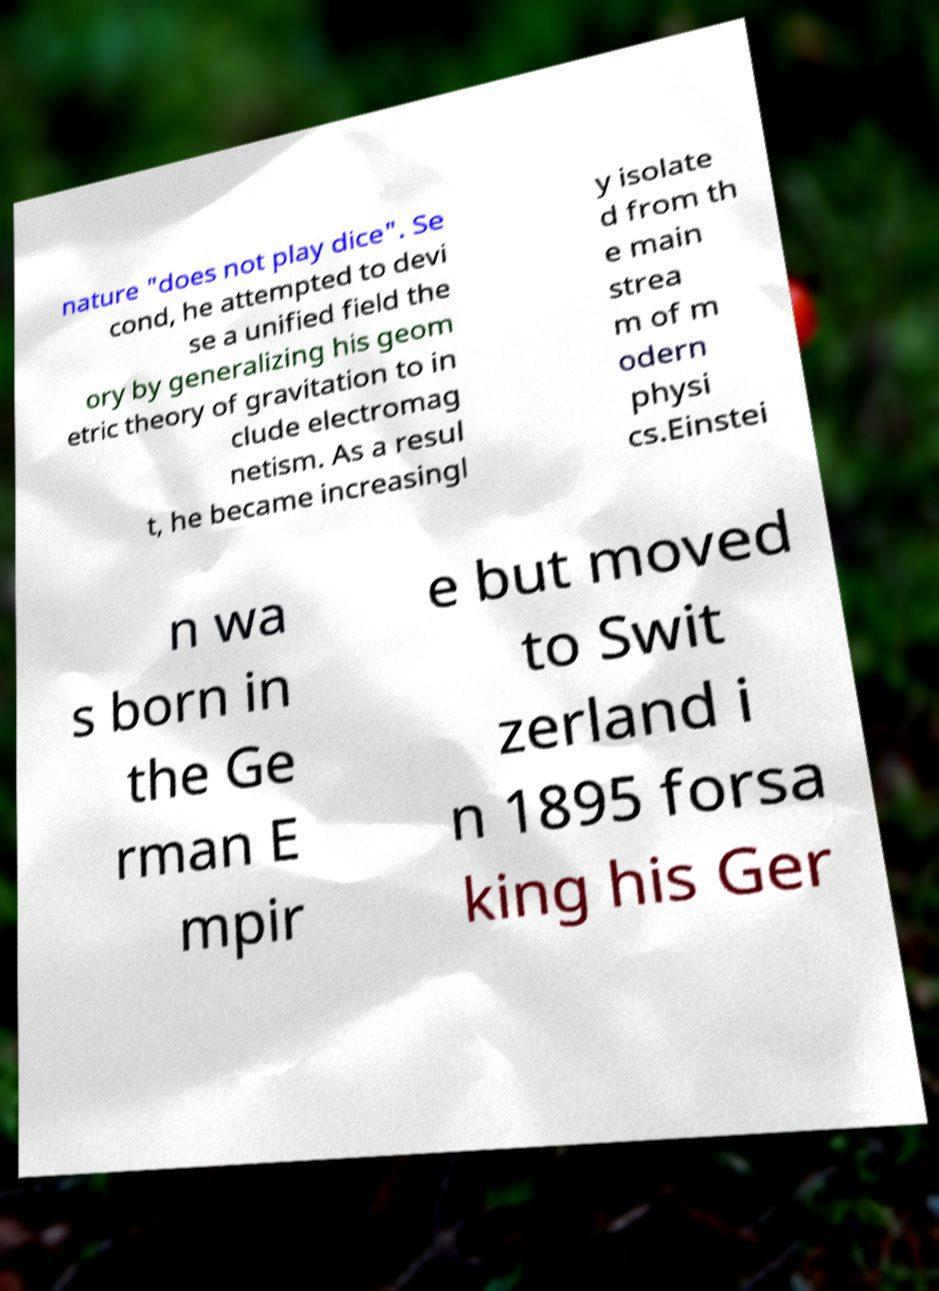Can you read and provide the text displayed in the image?This photo seems to have some interesting text. Can you extract and type it out for me? nature "does not play dice". Se cond, he attempted to devi se a unified field the ory by generalizing his geom etric theory of gravitation to in clude electromag netism. As a resul t, he became increasingl y isolate d from th e main strea m of m odern physi cs.Einstei n wa s born in the Ge rman E mpir e but moved to Swit zerland i n 1895 forsa king his Ger 